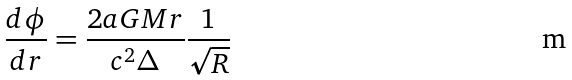<formula> <loc_0><loc_0><loc_500><loc_500>\frac { d \phi } { d r } = \frac { 2 a G M r } { c ^ { 2 } \Delta } \frac { 1 } { \sqrt { R } }</formula> 